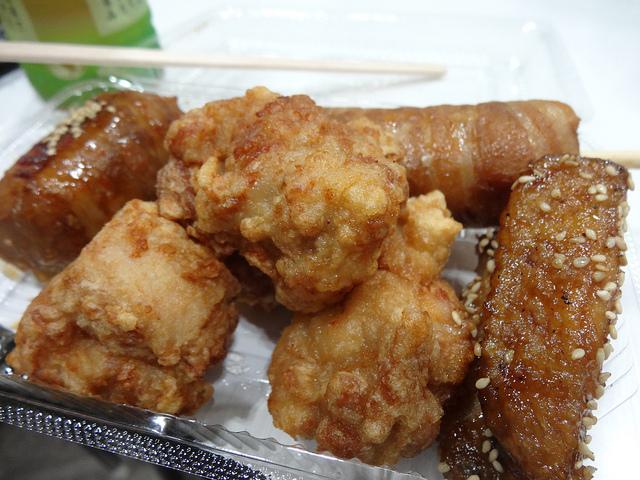How would a nutritionist rate this meal?
Quick response, please. Bad. What is this food?
Short answer required. Chicken. What kind of container is the food in?
Keep it brief. Plastic. Is the food fatty?
Be succinct. Yes. 